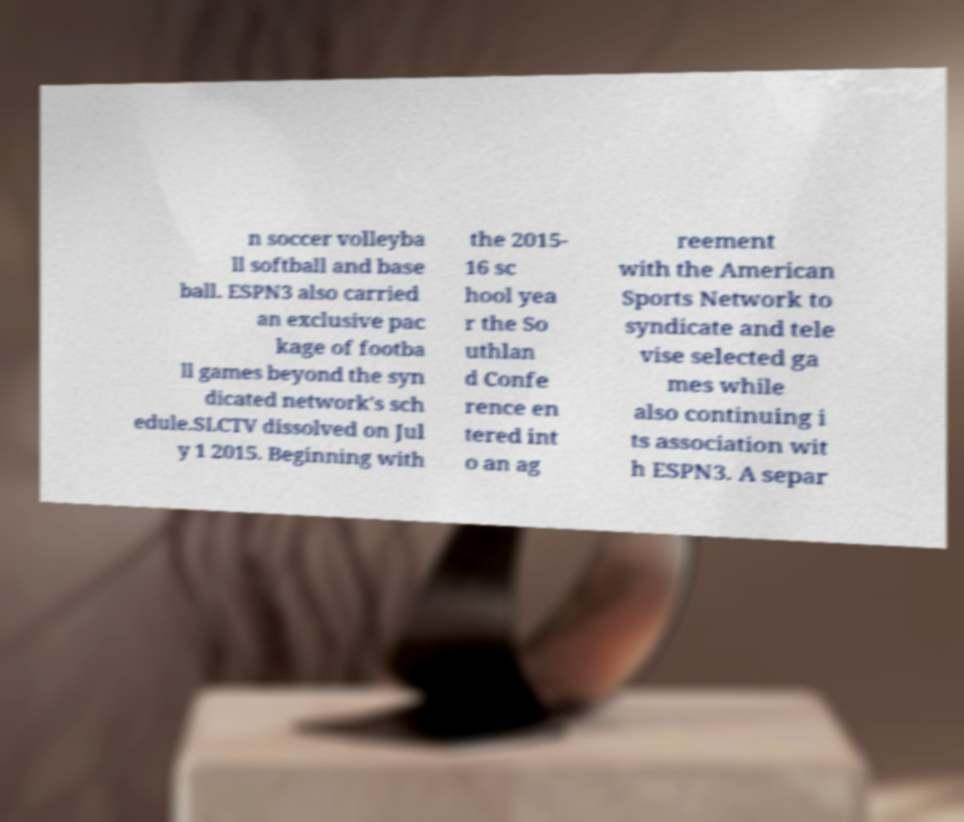Could you extract and type out the text from this image? n soccer volleyba ll softball and base ball. ESPN3 also carried an exclusive pac kage of footba ll games beyond the syn dicated network's sch edule.SLCTV dissolved on Jul y 1 2015. Beginning with the 2015- 16 sc hool yea r the So uthlan d Confe rence en tered int o an ag reement with the American Sports Network to syndicate and tele vise selected ga mes while also continuing i ts association wit h ESPN3. A separ 